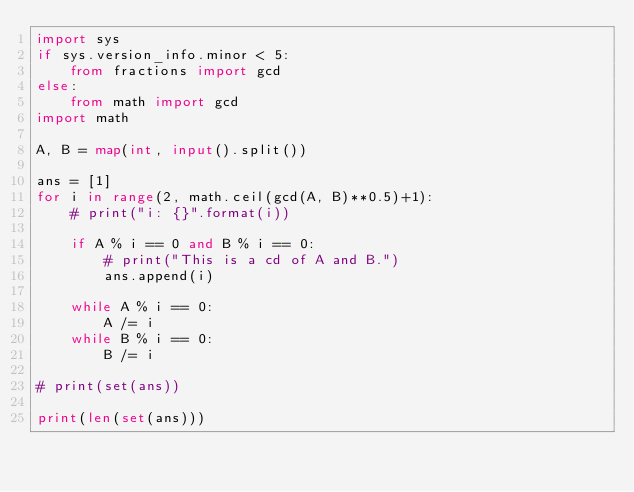<code> <loc_0><loc_0><loc_500><loc_500><_Python_>import sys
if sys.version_info.minor < 5:
    from fractions import gcd
else:
    from math import gcd
import math

A, B = map(int, input().split())

ans = [1]
for i in range(2, math.ceil(gcd(A, B)**0.5)+1):
    # print("i: {}".format(i))

    if A % i == 0 and B % i == 0:
        # print("This is a cd of A and B.")
        ans.append(i)

    while A % i == 0:
        A /= i
    while B % i == 0:
        B /= i

# print(set(ans))

print(len(set(ans)))
</code> 